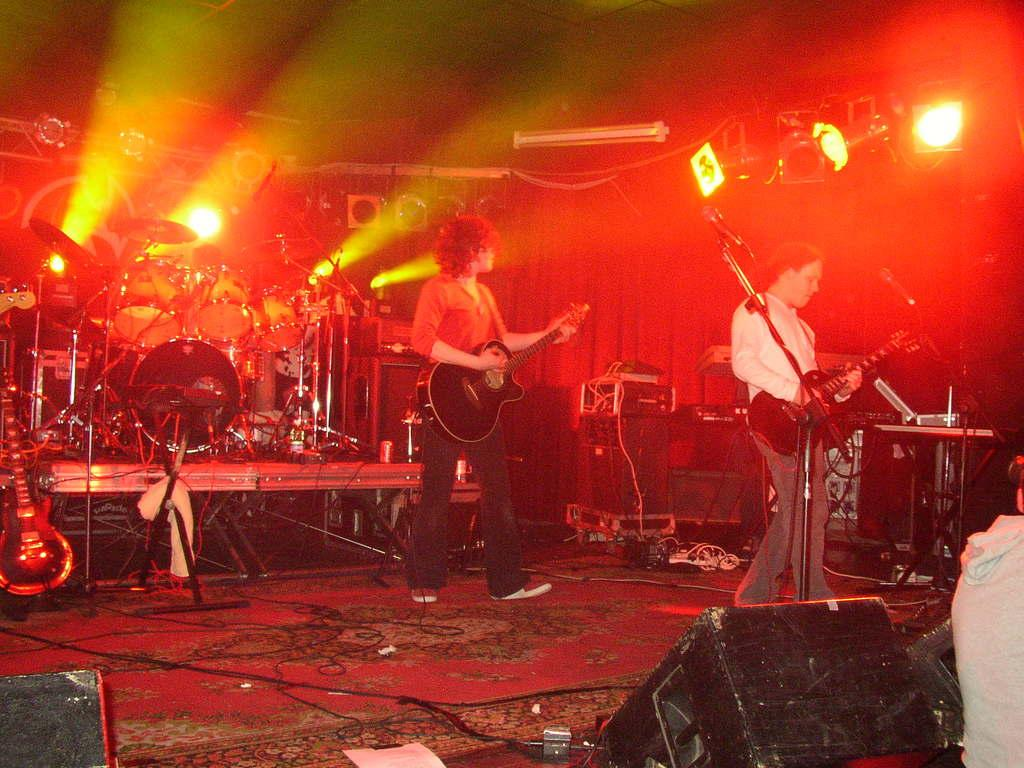How many people are in the image? There are two people in the image. What are the two people doing in the image? The two people are standing and playing guitars. What other musical equipment can be seen in the image? There are drums and other music equipment in the image. What can be observed in the background of the image? There are many lights in the background of the image. What type of fruit is being used as an apparatus in the image? There is no fruit being used as an apparatus in the image; the people are playing guitars and there are drums and other music equipment present. Is there a bike visible in the image? No, there is no bike present in the image. 